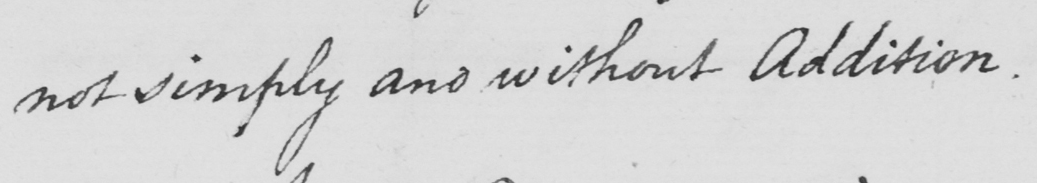Please provide the text content of this handwritten line. not simply and without Addition . 